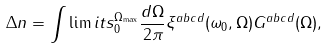Convert formula to latex. <formula><loc_0><loc_0><loc_500><loc_500>\Delta n = \int \lim i t s _ { 0 } ^ { \Omega _ { \max } } \frac { d \Omega } { 2 \pi } \xi ^ { a b c d } ( \omega _ { 0 } , \Omega ) G ^ { a b c d } ( \Omega ) ,</formula> 